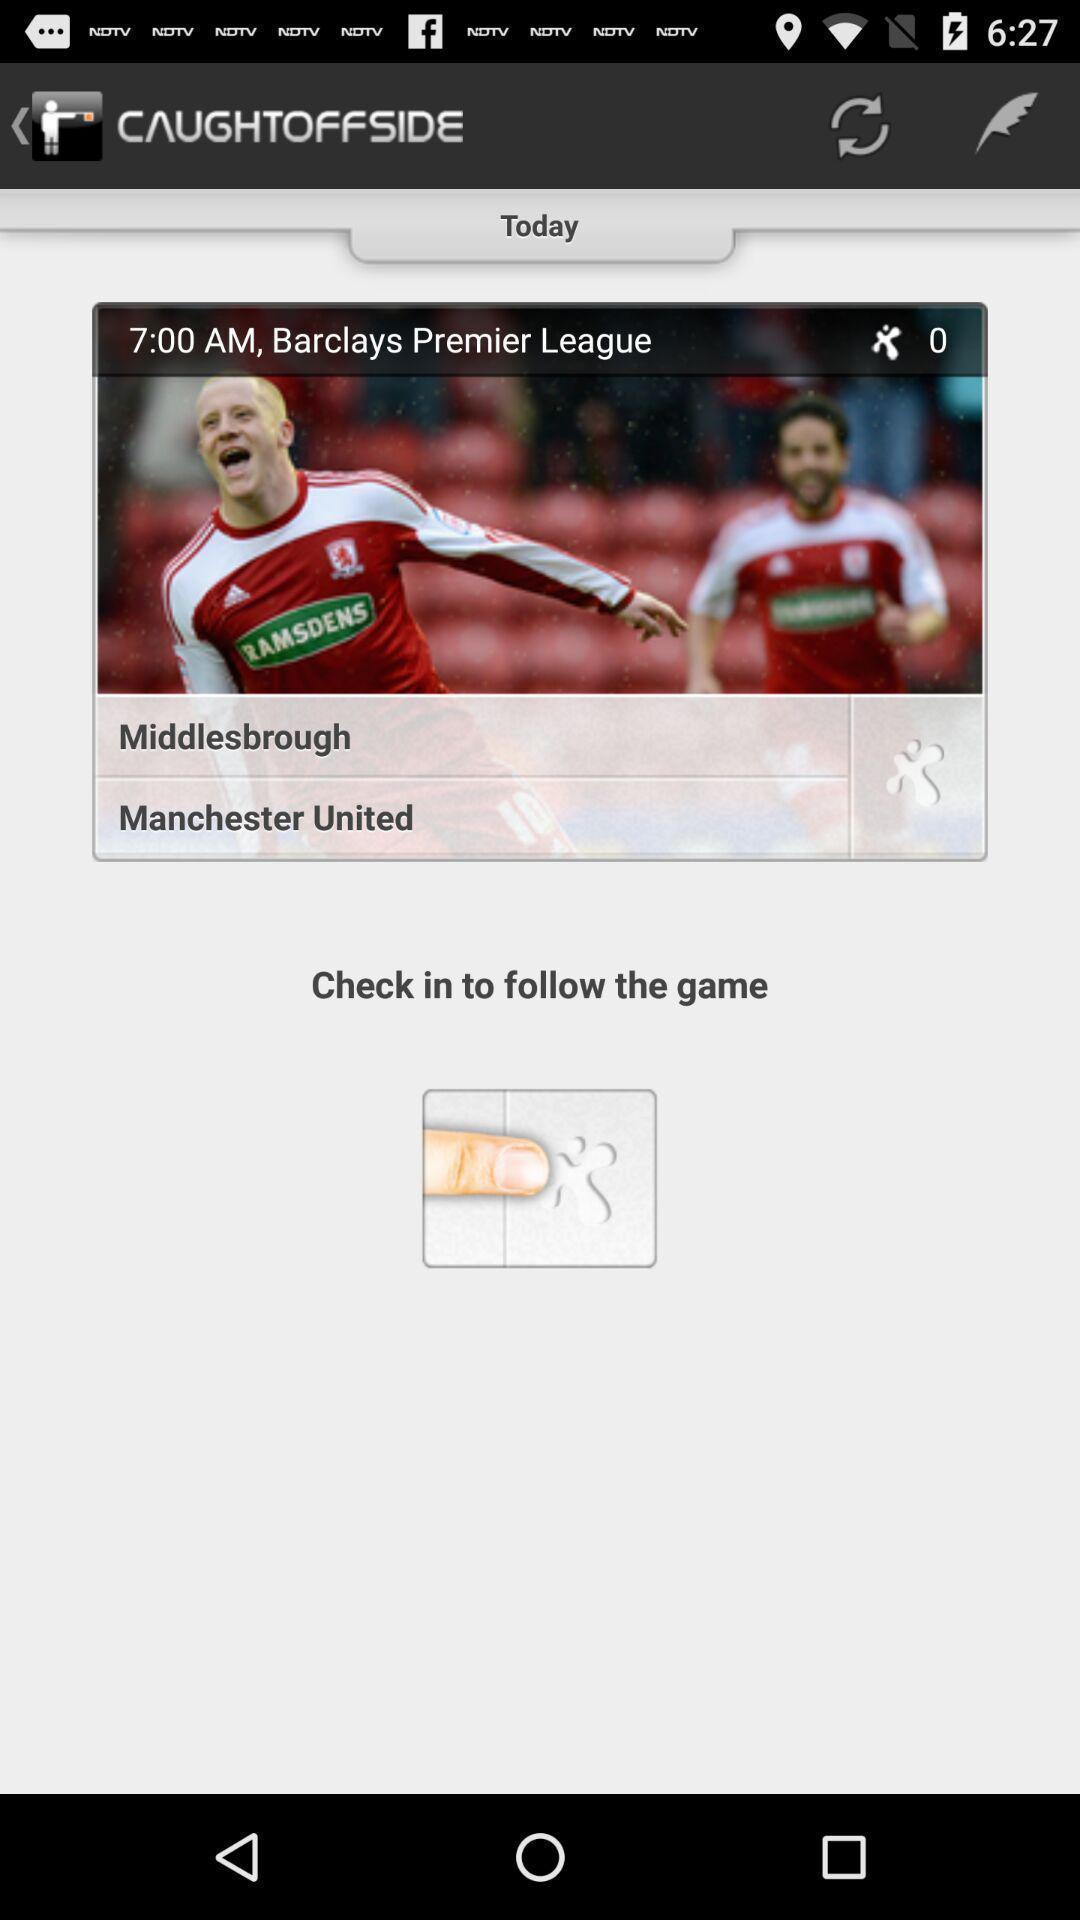Tell me about the visual elements in this screen capture. Updates of particular day in a sports website. 